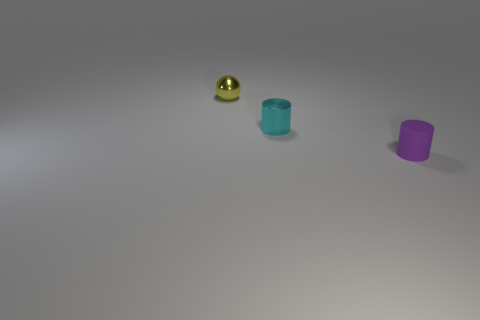Add 1 shiny objects. How many objects exist? 4 Subtract all spheres. How many objects are left? 2 Add 2 big gray spheres. How many big gray spheres exist? 2 Subtract 0 red cubes. How many objects are left? 3 Subtract all small things. Subtract all red things. How many objects are left? 0 Add 2 yellow metallic spheres. How many yellow metallic spheres are left? 3 